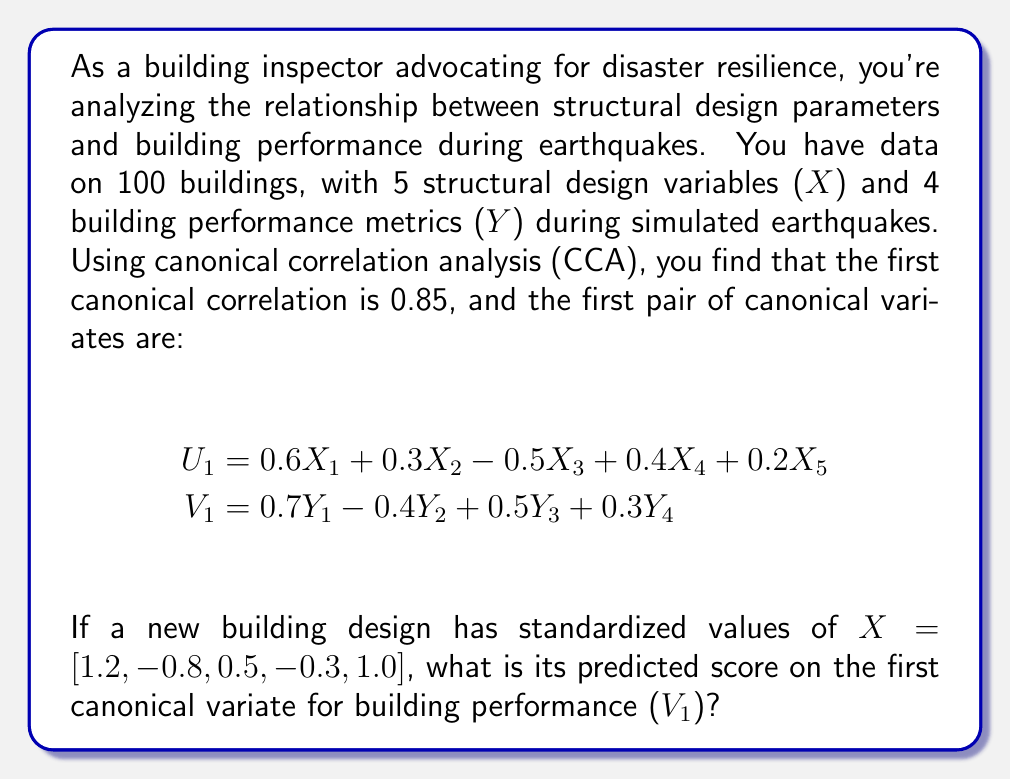Could you help me with this problem? To solve this problem, we need to follow these steps:

1. Understand the given information:
   - We have the first canonical correlation (0.85) and the first pair of canonical variates (U₁ and V₁).
   - We're given standardized values for a new building design's structural parameters (X).

2. Calculate the U₁ score for the new building design:
   U₁ = 0.6X₁ + 0.3X₂ - 0.5X₃ + 0.4X₄ + 0.2X₅
   
   Substituting the given X values:
   U₁ = 0.6(1.2) + 0.3(-0.8) - 0.5(0.5) + 0.4(-0.3) + 0.2(1.0)
   
   U₁ = 0.72 - 0.24 - 0.25 - 0.12 + 0.2
   
   U₁ = 0.31

3. Use the canonical correlation to predict V₁:
   The canonical correlation (0.85) represents the correlation between U₁ and V₁. We can use this to predict V₁ from U₁:

   V₁ ≈ r × U₁, where r is the canonical correlation

   V₁ ≈ 0.85 × 0.31 = 0.2635

Therefore, the predicted score on the first canonical variate for building performance (V₁) for the new building design is approximately 0.2635.
Answer: 0.2635 